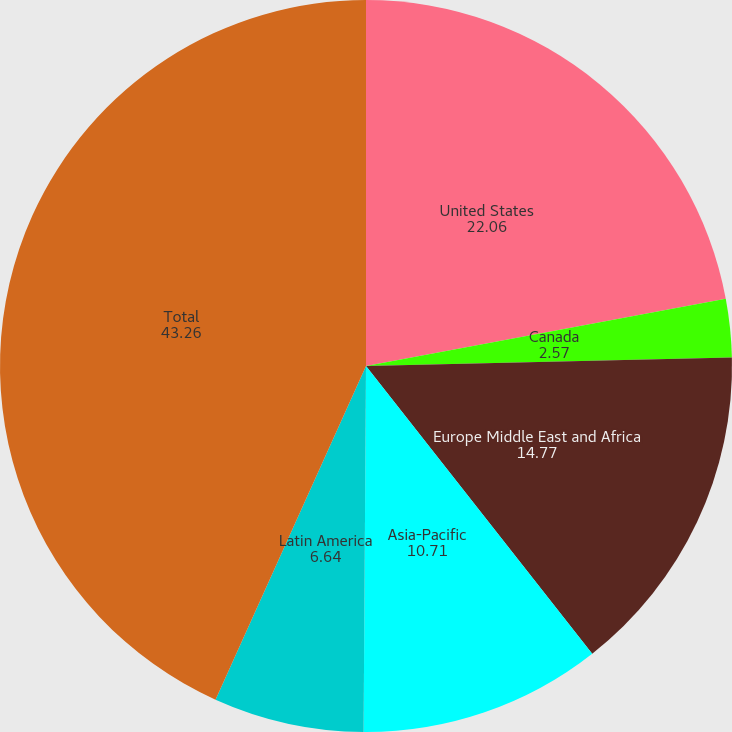<chart> <loc_0><loc_0><loc_500><loc_500><pie_chart><fcel>United States<fcel>Canada<fcel>Europe Middle East and Africa<fcel>Asia-Pacific<fcel>Latin America<fcel>Total<nl><fcel>22.06%<fcel>2.57%<fcel>14.77%<fcel>10.71%<fcel>6.64%<fcel>43.26%<nl></chart> 